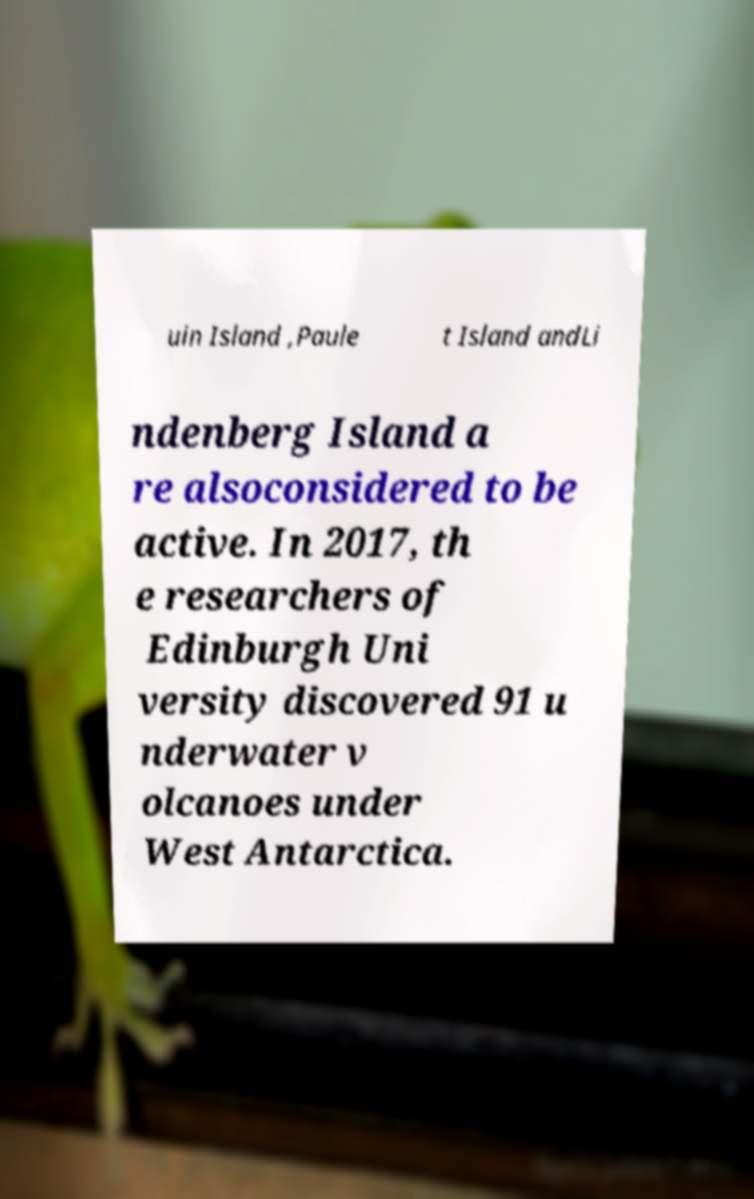I need the written content from this picture converted into text. Can you do that? uin Island ,Paule t Island andLi ndenberg Island a re alsoconsidered to be active. In 2017, th e researchers of Edinburgh Uni versity discovered 91 u nderwater v olcanoes under West Antarctica. 